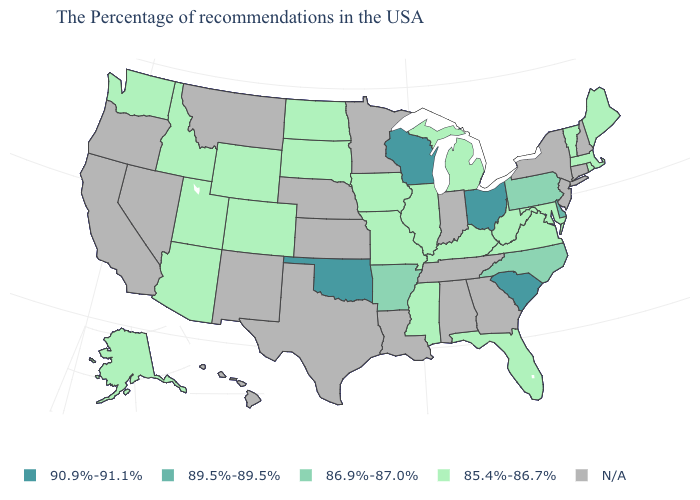What is the value of Wyoming?
Keep it brief. 85.4%-86.7%. What is the lowest value in the USA?
Write a very short answer. 85.4%-86.7%. Name the states that have a value in the range 85.4%-86.7%?
Answer briefly. Maine, Massachusetts, Rhode Island, Vermont, Maryland, Virginia, West Virginia, Florida, Michigan, Kentucky, Illinois, Mississippi, Missouri, Iowa, South Dakota, North Dakota, Wyoming, Colorado, Utah, Arizona, Idaho, Washington, Alaska. What is the value of Louisiana?
Quick response, please. N/A. Name the states that have a value in the range 89.5%-89.5%?
Keep it brief. Delaware. Name the states that have a value in the range 85.4%-86.7%?
Concise answer only. Maine, Massachusetts, Rhode Island, Vermont, Maryland, Virginia, West Virginia, Florida, Michigan, Kentucky, Illinois, Mississippi, Missouri, Iowa, South Dakota, North Dakota, Wyoming, Colorado, Utah, Arizona, Idaho, Washington, Alaska. Does the map have missing data?
Keep it brief. Yes. What is the value of Connecticut?
Give a very brief answer. N/A. Is the legend a continuous bar?
Quick response, please. No. Does Wisconsin have the lowest value in the USA?
Write a very short answer. No. Name the states that have a value in the range N/A?
Concise answer only. New Hampshire, Connecticut, New York, New Jersey, Georgia, Indiana, Alabama, Tennessee, Louisiana, Minnesota, Kansas, Nebraska, Texas, New Mexico, Montana, Nevada, California, Oregon, Hawaii. What is the value of Delaware?
Answer briefly. 89.5%-89.5%. Which states hav the highest value in the South?
Be succinct. South Carolina, Oklahoma. Name the states that have a value in the range 86.9%-87.0%?
Keep it brief. Pennsylvania, North Carolina, Arkansas. Does Oklahoma have the highest value in the USA?
Keep it brief. Yes. 